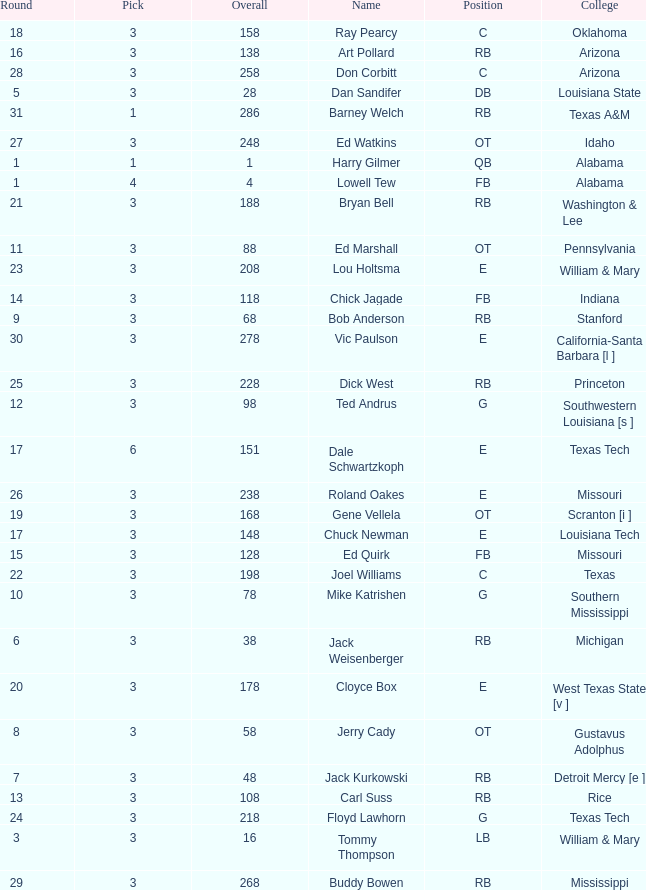Which pick has a Round smaller than 8, and an Overall smaller than 16, and a Name of harry gilmer? 1.0. 